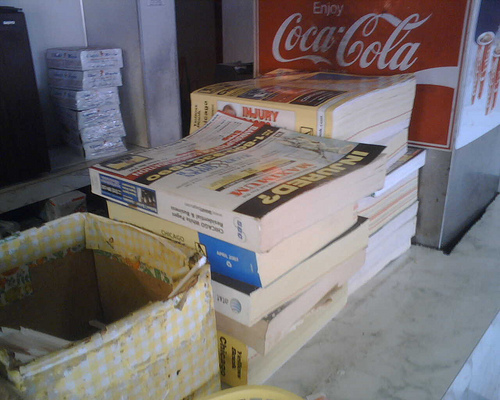<image>What are in the little white squares behind the books? It is ambiguous what are in the little white squares behind the books. It can be anything from cases of soda, tiles, bars of soap, tissues, copy paper, candles, pies, paper stacks or matches. What are in the little white squares behind the books? I am not sure what are in the little white squares behind the books. 